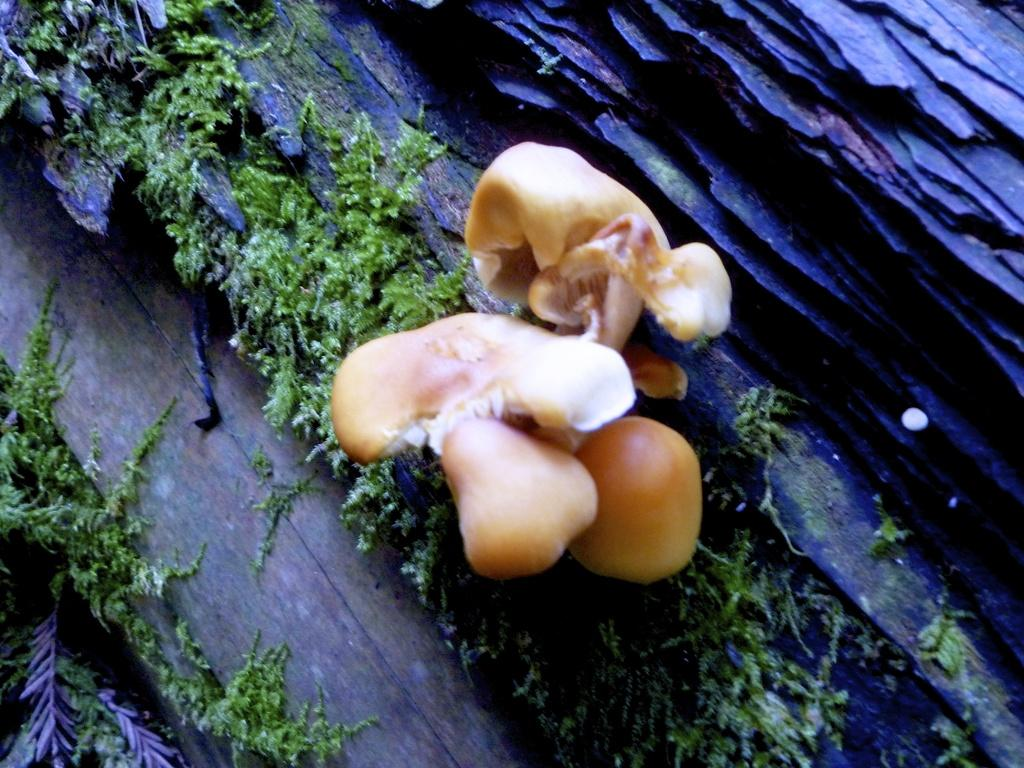What is the main subject of the image? There is a mushroom in the image. Can you describe the appearance of the mushroom? The mushroom is brown and cream in color. Where is the mushroom located? The mushroom is on a wooden surface. How would you describe the wooden surface? The wooden surface is black in color. What other natural element can be seen in the image? There is grass in the image. What color is the grass? The grass is green in color. What type of paste is being used to create the bomb in the image? There is no paste or bomb present in the image; it features a mushroom on a wooden surface and grass. What kind of rod can be seen interacting with the mushroom in the image? There is no rod present in the image; only the mushroom, wooden surface, and grass are visible. 